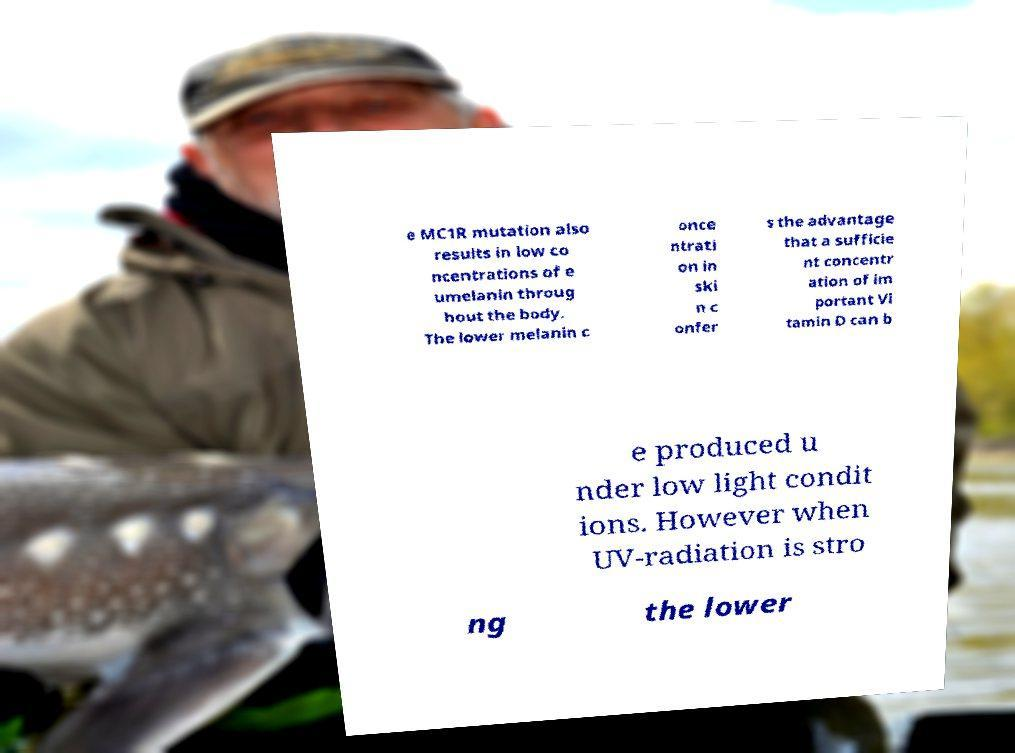Can you read and provide the text displayed in the image?This photo seems to have some interesting text. Can you extract and type it out for me? e MC1R mutation also results in low co ncentrations of e umelanin throug hout the body. The lower melanin c once ntrati on in ski n c onfer s the advantage that a sufficie nt concentr ation of im portant Vi tamin D can b e produced u nder low light condit ions. However when UV-radiation is stro ng the lower 